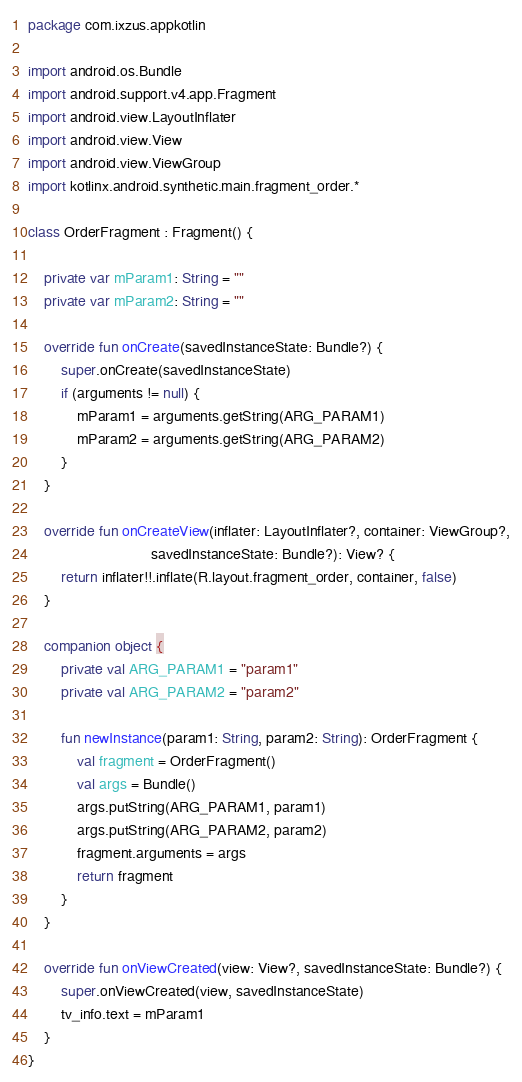Convert code to text. <code><loc_0><loc_0><loc_500><loc_500><_Kotlin_>package com.ixzus.appkotlin

import android.os.Bundle
import android.support.v4.app.Fragment
import android.view.LayoutInflater
import android.view.View
import android.view.ViewGroup
import kotlinx.android.synthetic.main.fragment_order.*

class OrderFragment : Fragment() {

    private var mParam1: String = ""
    private var mParam2: String = ""

    override fun onCreate(savedInstanceState: Bundle?) {
        super.onCreate(savedInstanceState)
        if (arguments != null) {
            mParam1 = arguments.getString(ARG_PARAM1)
            mParam2 = arguments.getString(ARG_PARAM2)
        }
    }

    override fun onCreateView(inflater: LayoutInflater?, container: ViewGroup?,
                              savedInstanceState: Bundle?): View? {
        return inflater!!.inflate(R.layout.fragment_order, container, false)
    }

    companion object {
        private val ARG_PARAM1 = "param1"
        private val ARG_PARAM2 = "param2"

        fun newInstance(param1: String, param2: String): OrderFragment {
            val fragment = OrderFragment()
            val args = Bundle()
            args.putString(ARG_PARAM1, param1)
            args.putString(ARG_PARAM2, param2)
            fragment.arguments = args
            return fragment
        }
    }

    override fun onViewCreated(view: View?, savedInstanceState: Bundle?) {
        super.onViewCreated(view, savedInstanceState)
        tv_info.text = mParam1
    }
}</code> 